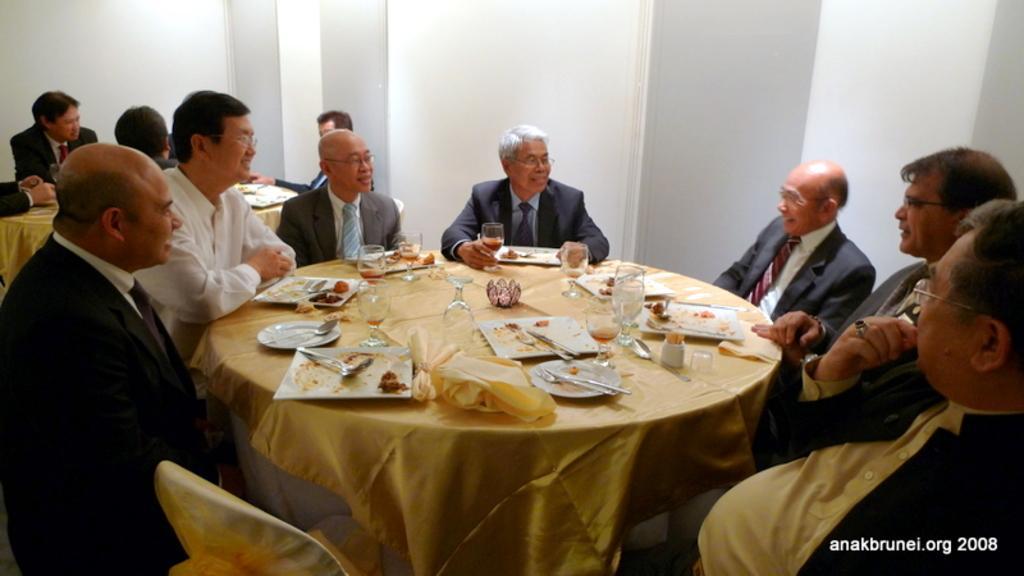Please provide a concise description of this image. In the given image we can see there are many men sitting on chair around the table. On the table we can see wine glass and food in a plate, fork and spoon. This is a watermark. This is a golden color cloth on the table. 